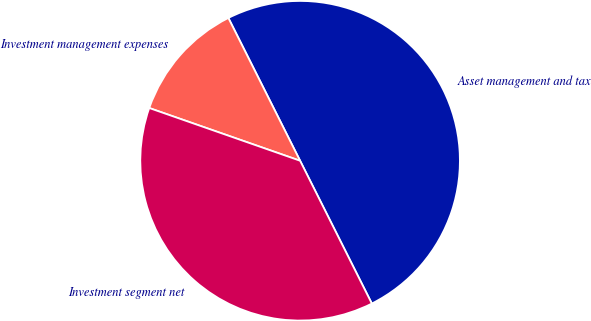<chart> <loc_0><loc_0><loc_500><loc_500><pie_chart><fcel>Asset management and tax<fcel>Investment management expenses<fcel>Investment segment net<nl><fcel>50.0%<fcel>12.24%<fcel>37.76%<nl></chart> 